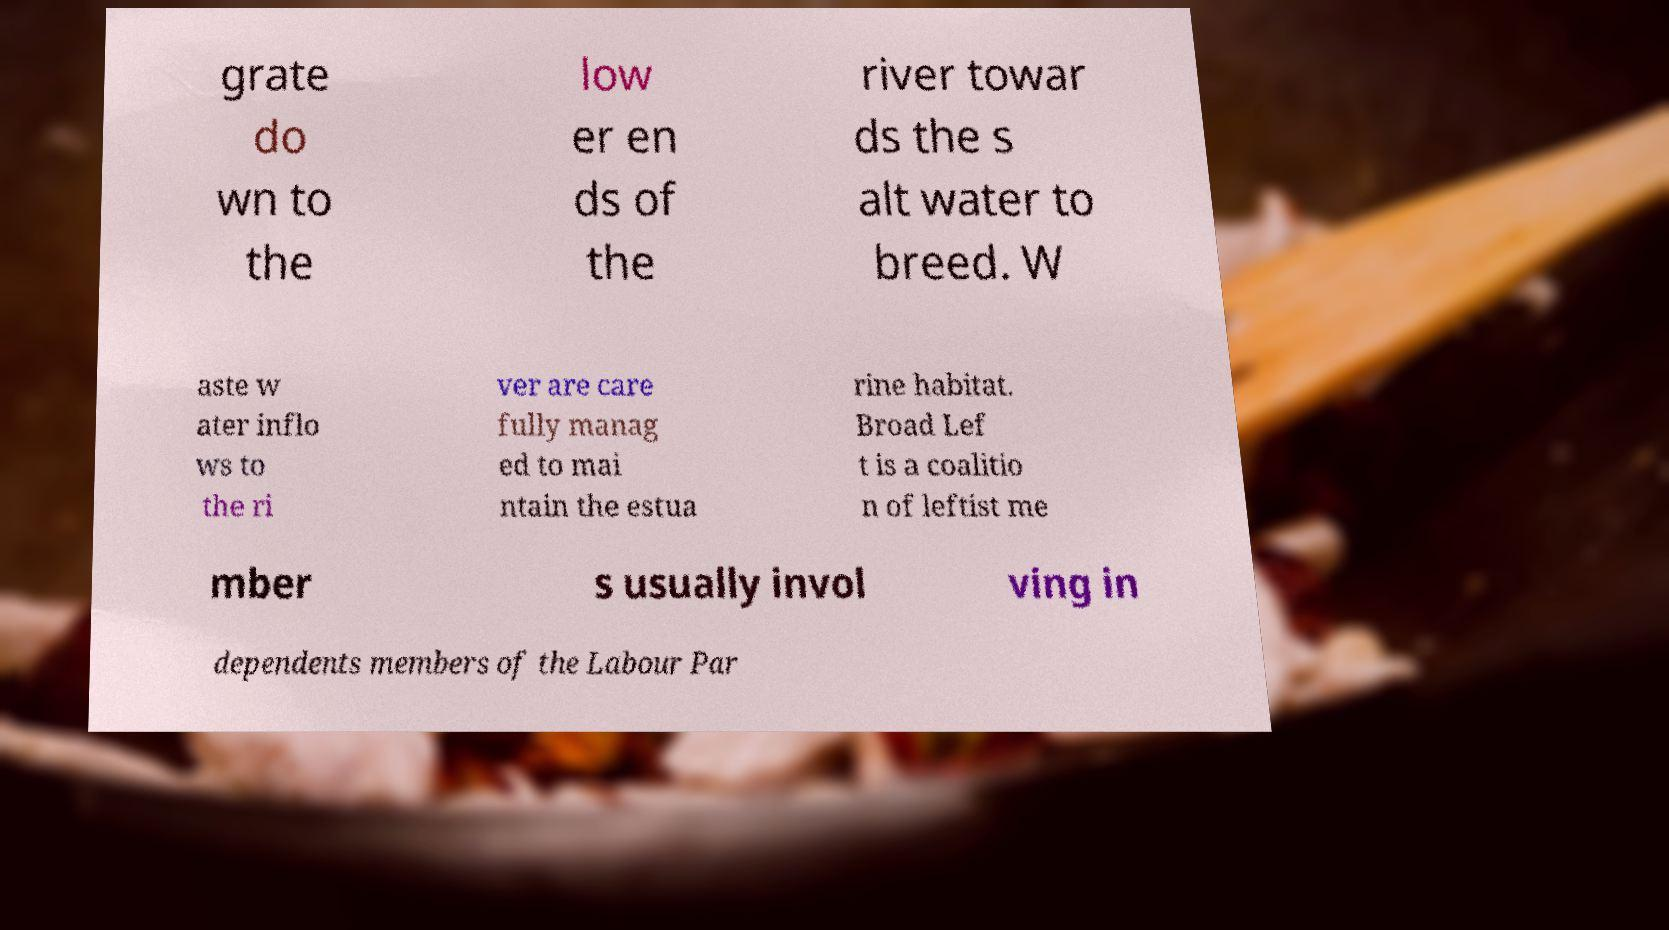For documentation purposes, I need the text within this image transcribed. Could you provide that? grate do wn to the low er en ds of the river towar ds the s alt water to breed. W aste w ater inflo ws to the ri ver are care fully manag ed to mai ntain the estua rine habitat. Broad Lef t is a coalitio n of leftist me mber s usually invol ving in dependents members of the Labour Par 